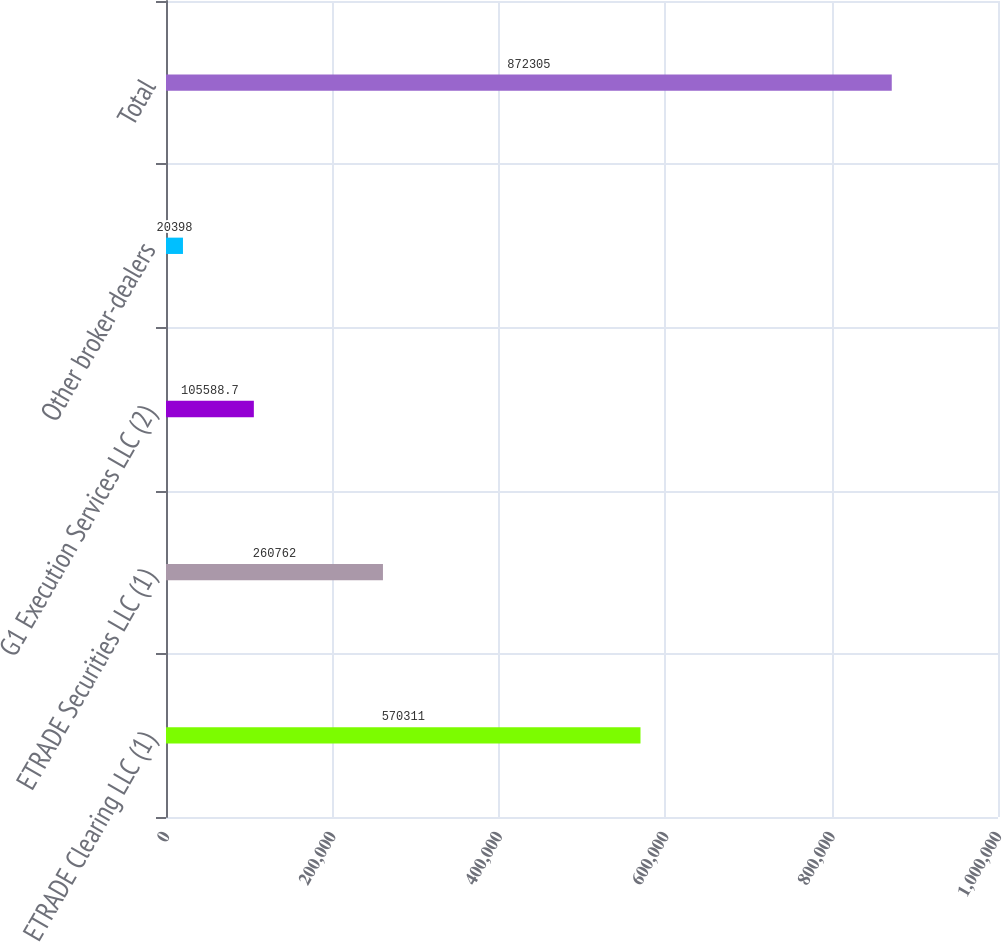Convert chart. <chart><loc_0><loc_0><loc_500><loc_500><bar_chart><fcel>ETRADE Clearing LLC (1)<fcel>ETRADE Securities LLC (1)<fcel>G1 Execution Services LLC (2)<fcel>Other broker-dealers<fcel>Total<nl><fcel>570311<fcel>260762<fcel>105589<fcel>20398<fcel>872305<nl></chart> 